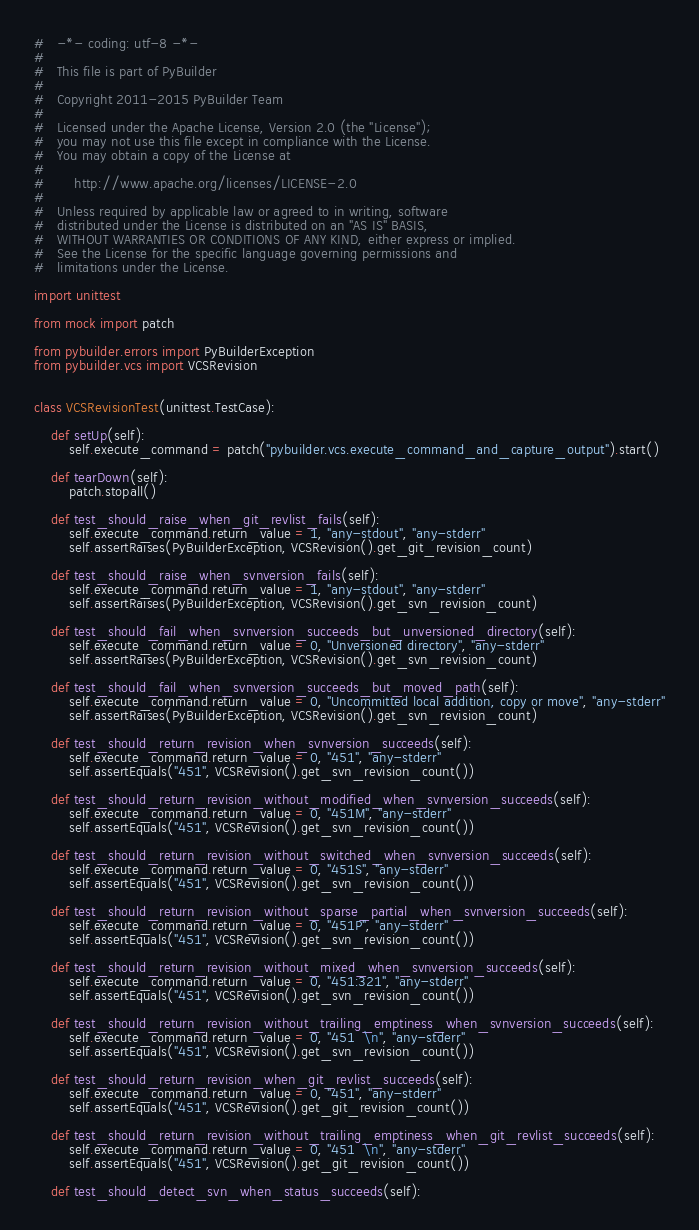<code> <loc_0><loc_0><loc_500><loc_500><_Python_>#   -*- coding: utf-8 -*-
#
#   This file is part of PyBuilder
#
#   Copyright 2011-2015 PyBuilder Team
#
#   Licensed under the Apache License, Version 2.0 (the "License");
#   you may not use this file except in compliance with the License.
#   You may obtain a copy of the License at
#
#       http://www.apache.org/licenses/LICENSE-2.0
#
#   Unless required by applicable law or agreed to in writing, software
#   distributed under the License is distributed on an "AS IS" BASIS,
#   WITHOUT WARRANTIES OR CONDITIONS OF ANY KIND, either express or implied.
#   See the License for the specific language governing permissions and
#   limitations under the License.

import unittest

from mock import patch

from pybuilder.errors import PyBuilderException
from pybuilder.vcs import VCSRevision


class VCSRevisionTest(unittest.TestCase):

    def setUp(self):
        self.execute_command = patch("pybuilder.vcs.execute_command_and_capture_output").start()

    def tearDown(self):
        patch.stopall()

    def test_should_raise_when_git_revlist_fails(self):
        self.execute_command.return_value = 1, "any-stdout", "any-stderr"
        self.assertRaises(PyBuilderException, VCSRevision().get_git_revision_count)

    def test_should_raise_when_svnversion_fails(self):
        self.execute_command.return_value = 1, "any-stdout", "any-stderr"
        self.assertRaises(PyBuilderException, VCSRevision().get_svn_revision_count)

    def test_should_fail_when_svnversion_succeeds_but_unversioned_directory(self):
        self.execute_command.return_value = 0, "Unversioned directory", "any-stderr"
        self.assertRaises(PyBuilderException, VCSRevision().get_svn_revision_count)

    def test_should_fail_when_svnversion_succeeds_but_moved_path(self):
        self.execute_command.return_value = 0, "Uncommitted local addition, copy or move", "any-stderr"
        self.assertRaises(PyBuilderException, VCSRevision().get_svn_revision_count)

    def test_should_return_revision_when_svnversion_succeeds(self):
        self.execute_command.return_value = 0, "451", "any-stderr"
        self.assertEquals("451", VCSRevision().get_svn_revision_count())

    def test_should_return_revision_without_modified_when_svnversion_succeeds(self):
        self.execute_command.return_value = 0, "451M", "any-stderr"
        self.assertEquals("451", VCSRevision().get_svn_revision_count())

    def test_should_return_revision_without_switched_when_svnversion_succeeds(self):
        self.execute_command.return_value = 0, "451S", "any-stderr"
        self.assertEquals("451", VCSRevision().get_svn_revision_count())

    def test_should_return_revision_without_sparse_partial_when_svnversion_succeeds(self):
        self.execute_command.return_value = 0, "451P", "any-stderr"
        self.assertEquals("451", VCSRevision().get_svn_revision_count())

    def test_should_return_revision_without_mixed_when_svnversion_succeeds(self):
        self.execute_command.return_value = 0, "451:321", "any-stderr"
        self.assertEquals("451", VCSRevision().get_svn_revision_count())

    def test_should_return_revision_without_trailing_emptiness_when_svnversion_succeeds(self):
        self.execute_command.return_value = 0, "451  \n", "any-stderr"
        self.assertEquals("451", VCSRevision().get_svn_revision_count())

    def test_should_return_revision_when_git_revlist_succeeds(self):
        self.execute_command.return_value = 0, "451", "any-stderr"
        self.assertEquals("451", VCSRevision().get_git_revision_count())

    def test_should_return_revision_without_trailing_emptiness_when_git_revlist_succeeds(self):
        self.execute_command.return_value = 0, "451  \n", "any-stderr"
        self.assertEquals("451", VCSRevision().get_git_revision_count())

    def test_should_detect_svn_when_status_succeeds(self):</code> 